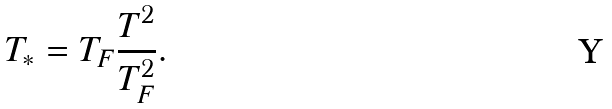<formula> <loc_0><loc_0><loc_500><loc_500>T _ { * } = T _ { F } \frac { T ^ { 2 } } { T _ { F } ^ { 2 } } .</formula> 